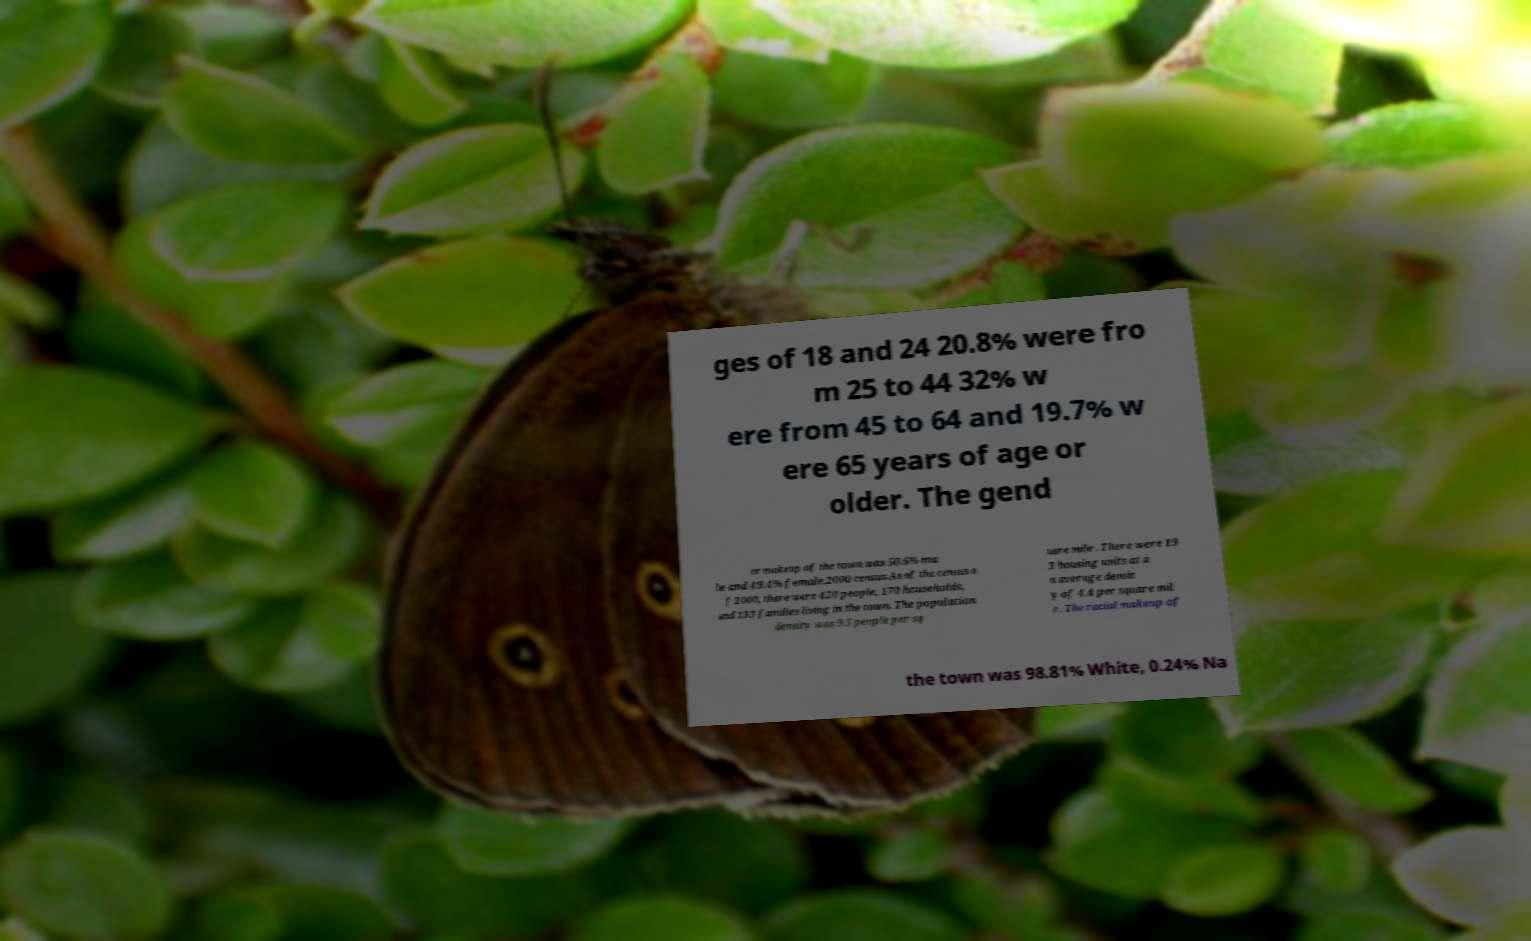Please identify and transcribe the text found in this image. ges of 18 and 24 20.8% were fro m 25 to 44 32% w ere from 45 to 64 and 19.7% w ere 65 years of age or older. The gend er makeup of the town was 50.6% ma le and 49.4% female.2000 census.As of the census o f 2000, there were 420 people, 170 households, and 133 families living in the town. The population density was 9.5 people per sq uare mile . There were 19 3 housing units at a n average densit y of 4.4 per square mil e . The racial makeup of the town was 98.81% White, 0.24% Na 